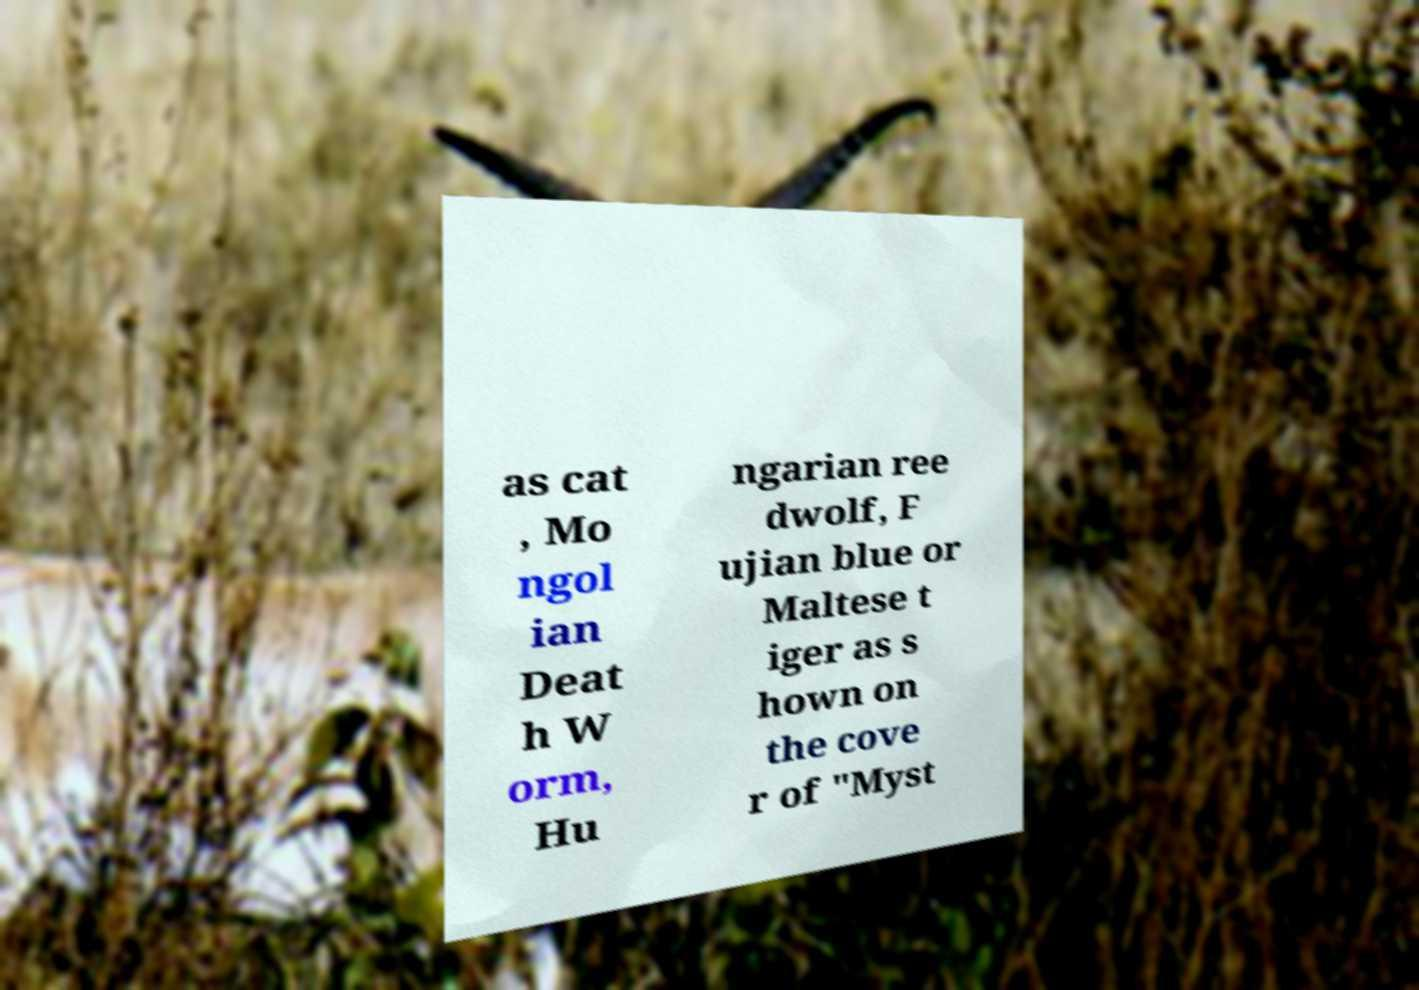Could you extract and type out the text from this image? as cat , Mo ngol ian Deat h W orm, Hu ngarian ree dwolf, F ujian blue or Maltese t iger as s hown on the cove r of "Myst 